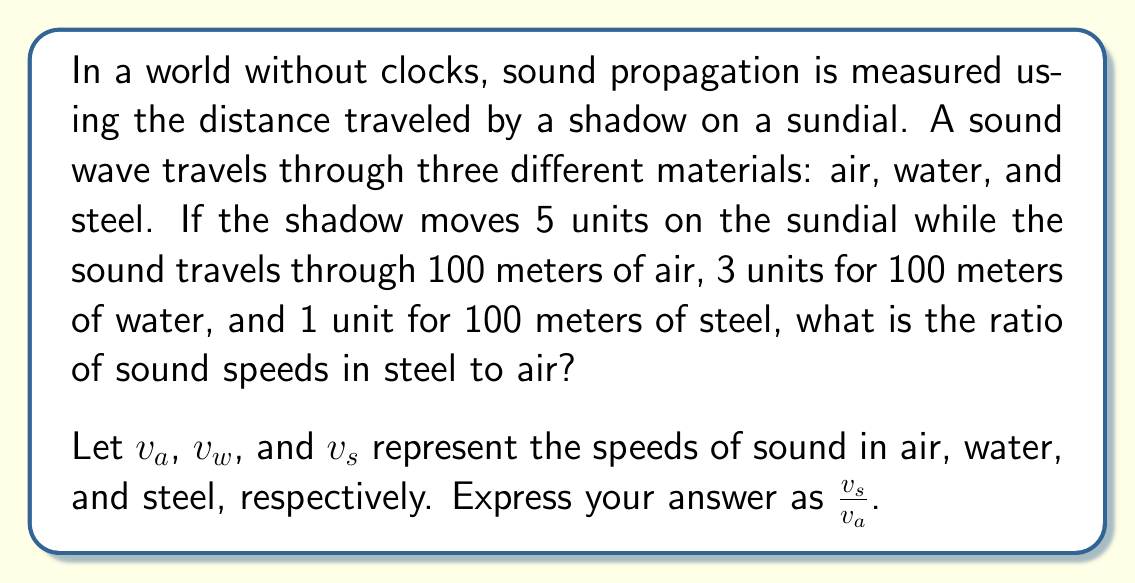Give your solution to this math problem. Let's approach this step-by-step:

1) First, we need to understand that the speed of sound is inversely proportional to the time taken to travel a fixed distance. In this case, the "time" is represented by the movement of the shadow on the sundial.

2) For air:
   100 meters are covered in 5 units of shadow movement
   So, $v_a \propto \frac{100}{5} = 20$

3) For water:
   100 meters are covered in 3 units of shadow movement
   So, $v_w \propto \frac{100}{3} \approx 33.33$

4) For steel:
   100 meters are covered in 1 unit of shadow movement
   So, $v_s \propto \frac{100}{1} = 100$

5) Now, we need to find the ratio of $\frac{v_s}{v_a}$:

   $$\frac{v_s}{v_a} = \frac{100}{20} = 5$$

Therefore, the speed of sound in steel is 5 times the speed of sound in air.
Answer: 5 